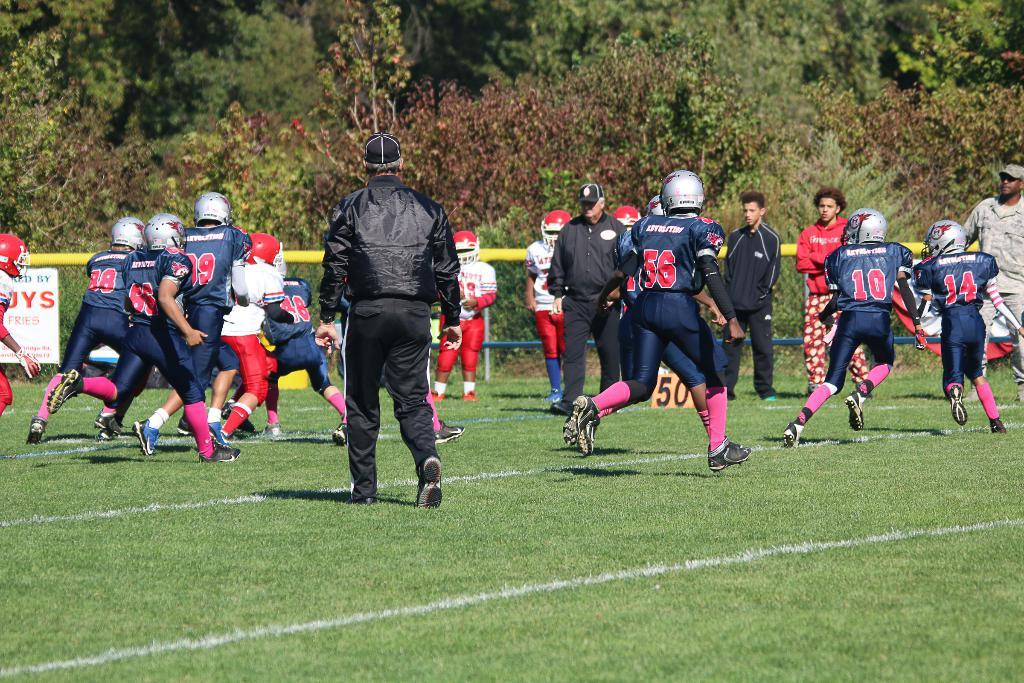What activity are the people in the image engaged in? The people in the image are playing a game. What type of surface is at the bottom of the image? There is grass on the surface at the bottom of the image. What type of barrier is present in the image? There is a metal fence in the image. What can be seen in the background of the image? There are trees in the background of the image. Can you see any airplanes taking off at the airport in the image? There is no airport or airplanes present in the image. What type of pot is being used by the people playing the game in the image? There is no pot visible in the image; the people are playing a game on a grassy surface with a metal fence in the background. 